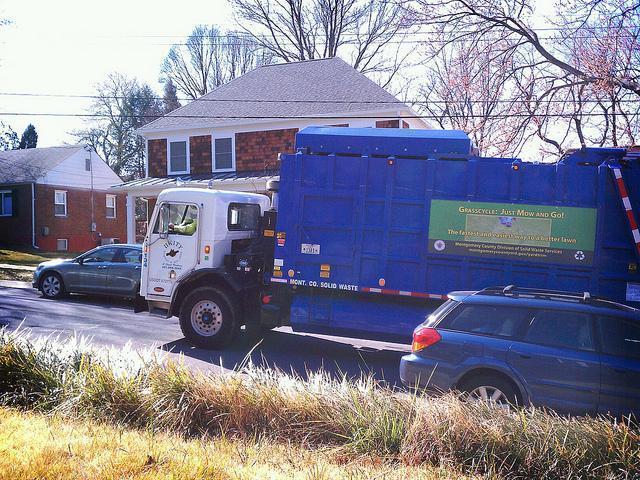How many trucks are there?
Give a very brief answer. 1. How many cars are in the picture?
Give a very brief answer. 2. How many blue box by the red couch and located on the left of the coffee table ?
Give a very brief answer. 0. 